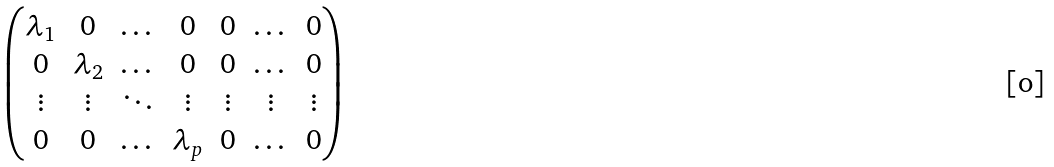Convert formula to latex. <formula><loc_0><loc_0><loc_500><loc_500>\begin{pmatrix} \lambda _ { 1 } & 0 & \dots & 0 & 0 & \dots & 0 \\ 0 & \lambda _ { 2 } & \dots & 0 & 0 & \dots & 0 \\ \vdots & \vdots & \ddots & \vdots & \vdots & \vdots & \vdots \\ 0 & 0 & \dots & \lambda _ { p } & 0 & \dots & 0 \end{pmatrix}</formula> 